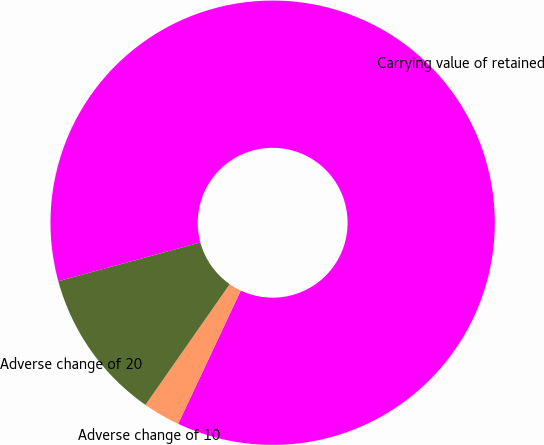<chart> <loc_0><loc_0><loc_500><loc_500><pie_chart><fcel>Carrying value of retained<fcel>Adverse change of 10<fcel>Adverse change of 20<nl><fcel>86.23%<fcel>2.71%<fcel>11.06%<nl></chart> 